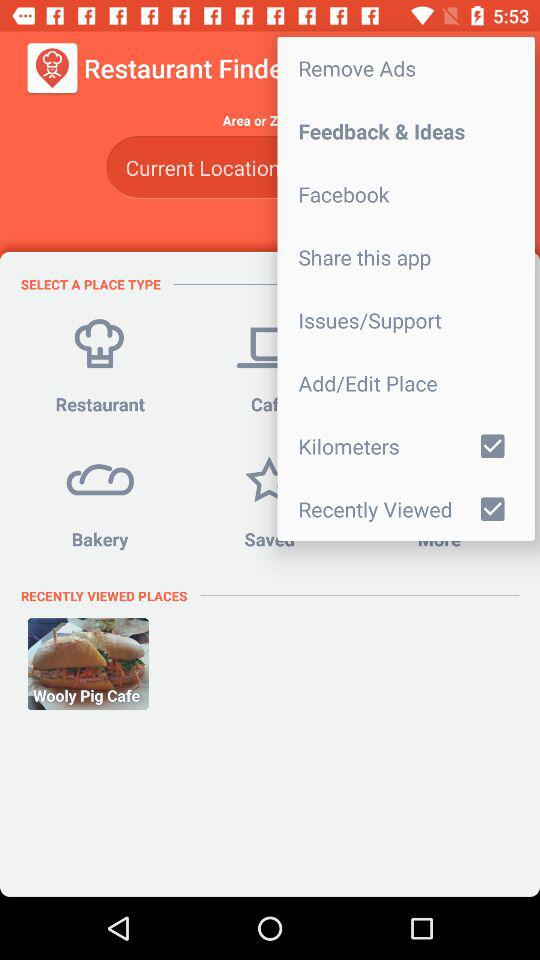Which option is selected? The selected options are "Kilometers" and "Recently Viewed". 